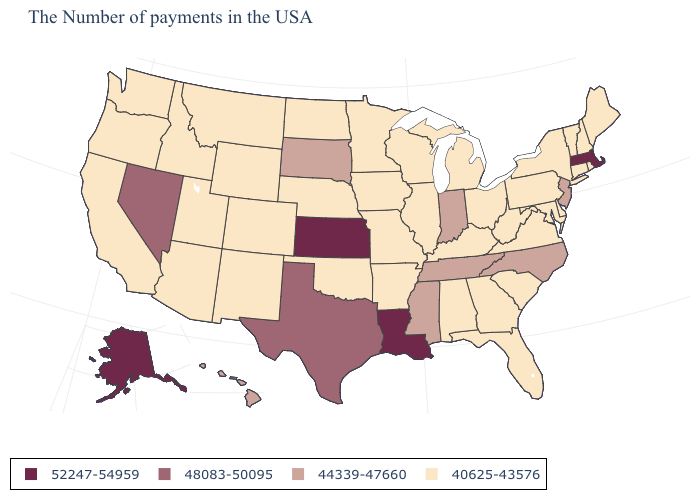What is the value of Louisiana?
Concise answer only. 52247-54959. What is the value of Montana?
Short answer required. 40625-43576. Which states hav the highest value in the West?
Be succinct. Alaska. What is the value of Kansas?
Concise answer only. 52247-54959. Name the states that have a value in the range 44339-47660?
Answer briefly. New Jersey, North Carolina, Indiana, Tennessee, Mississippi, South Dakota, Hawaii. Does Maryland have the highest value in the USA?
Give a very brief answer. No. Which states have the lowest value in the USA?
Quick response, please. Maine, Rhode Island, New Hampshire, Vermont, Connecticut, New York, Delaware, Maryland, Pennsylvania, Virginia, South Carolina, West Virginia, Ohio, Florida, Georgia, Michigan, Kentucky, Alabama, Wisconsin, Illinois, Missouri, Arkansas, Minnesota, Iowa, Nebraska, Oklahoma, North Dakota, Wyoming, Colorado, New Mexico, Utah, Montana, Arizona, Idaho, California, Washington, Oregon. What is the value of Arkansas?
Give a very brief answer. 40625-43576. Name the states that have a value in the range 44339-47660?
Give a very brief answer. New Jersey, North Carolina, Indiana, Tennessee, Mississippi, South Dakota, Hawaii. What is the lowest value in states that border Missouri?
Answer briefly. 40625-43576. Name the states that have a value in the range 44339-47660?
Answer briefly. New Jersey, North Carolina, Indiana, Tennessee, Mississippi, South Dakota, Hawaii. What is the value of Tennessee?
Answer briefly. 44339-47660. Does Connecticut have the lowest value in the USA?
Be succinct. Yes. What is the lowest value in the MidWest?
Answer briefly. 40625-43576. Name the states that have a value in the range 44339-47660?
Quick response, please. New Jersey, North Carolina, Indiana, Tennessee, Mississippi, South Dakota, Hawaii. 